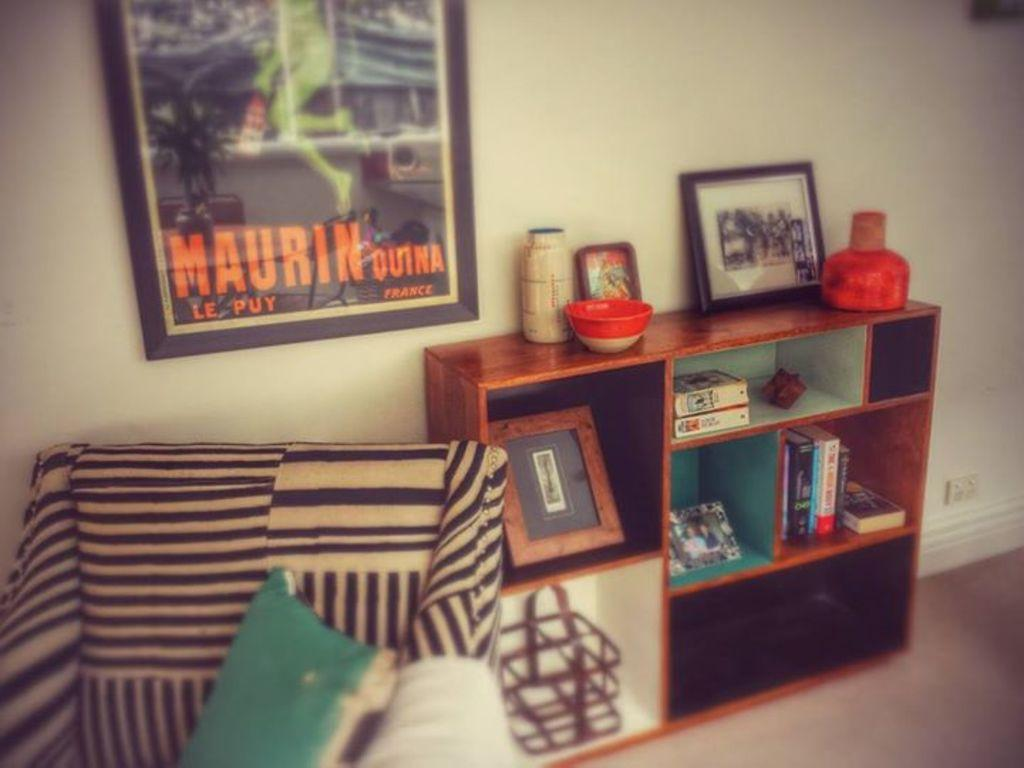Provide a one-sentence caption for the provided image. A living room with a Maurin Outna picture from France. 